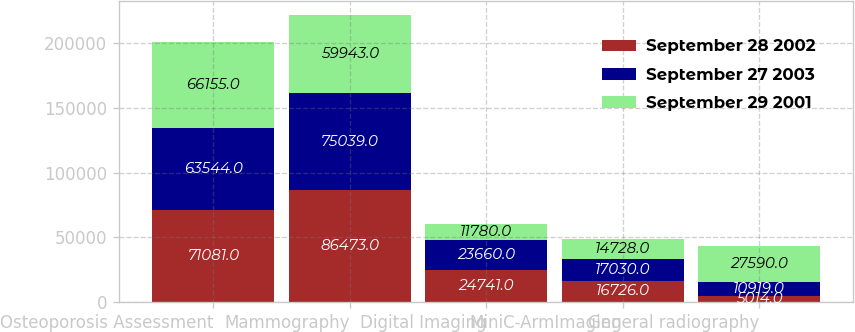<chart> <loc_0><loc_0><loc_500><loc_500><stacked_bar_chart><ecel><fcel>Osteoporosis Assessment<fcel>Mammography<fcel>Digital Imaging<fcel>MiniC-ArmImaging<fcel>General radiography<nl><fcel>September 28 2002<fcel>71081<fcel>86473<fcel>24741<fcel>16726<fcel>5014<nl><fcel>September 27 2003<fcel>63544<fcel>75039<fcel>23660<fcel>17030<fcel>10919<nl><fcel>September 29 2001<fcel>66155<fcel>59943<fcel>11780<fcel>14728<fcel>27590<nl></chart> 